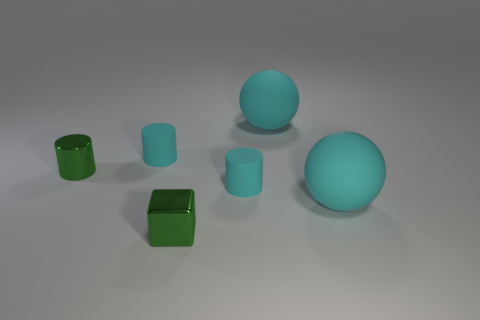Add 3 large matte spheres. How many objects exist? 9 Subtract all blocks. How many objects are left? 5 Subtract 0 purple cubes. How many objects are left? 6 Subtract all large objects. Subtract all green cubes. How many objects are left? 3 Add 6 tiny cyan matte objects. How many tiny cyan matte objects are left? 8 Add 4 cyan things. How many cyan things exist? 8 